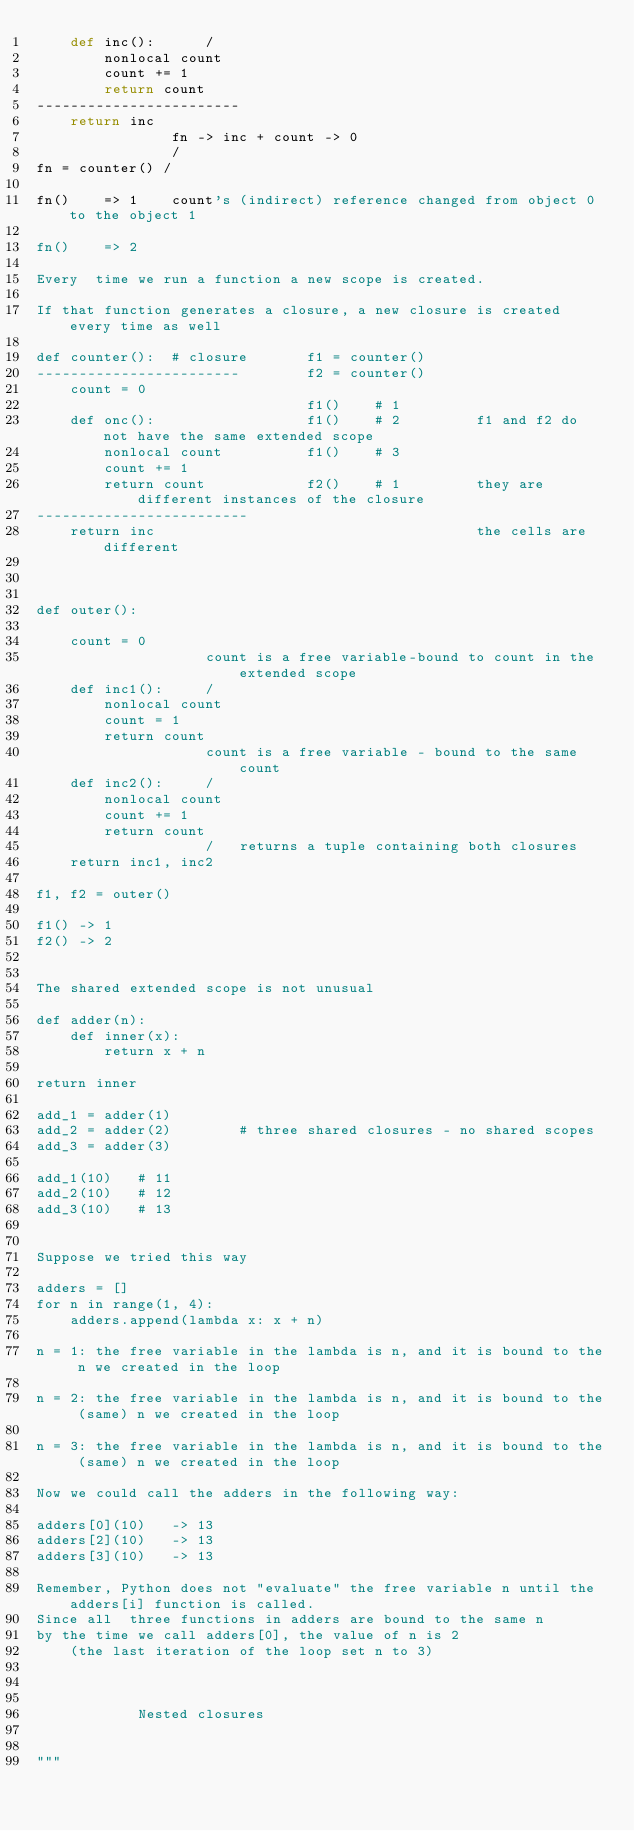<code> <loc_0><loc_0><loc_500><loc_500><_Python_>    def inc():      /
        nonlocal count
        count += 1
        return count
------------------------
    return inc
                fn -> inc + count -> 0
                /
fn = counter() /

fn()    => 1    count's (indirect) reference changed from object 0 to the object 1

fn()    => 2

Every  time we run a function a new scope is created.

If that function generates a closure, a new closure is created every time as well

def counter():  # closure       f1 = counter()
------------------------        f2 = counter()
    count = 0
                                f1()    # 1
    def onc():                  f1()    # 2         f1 and f2 do not have the same extended scope
        nonlocal count          f1()    # 3
        count += 1
        return count            f2()    # 1         they are different instances of the closure
-------------------------
    return inc                                      the cells are different



def outer():

    count = 0
                    count is a free variable-bound to count in the extended scope
    def inc1():     /
        nonlocal count
        count = 1
        return count
                    count is a free variable - bound to the same count
    def inc2():     /
        nonlocal count
        count += 1
        return count
                    /   returns a tuple containing both closures
    return inc1, inc2

f1, f2 = outer()

f1() -> 1
f2() -> 2


The shared extended scope is not unusual

def adder(n):
    def inner(x):
        return x + n

return inner

add_1 = adder(1)
add_2 = adder(2)        # three shared closures - no shared scopes
add_3 = adder(3)

add_1(10)   # 11
add_2(10)   # 12
add_3(10)   # 13


Suppose we tried this way

adders = []
for n in range(1, 4):
    adders.append(lambda x: x + n)

n = 1: the free variable in the lambda is n, and it is bound to the n we created in the loop

n = 2: the free variable in the lambda is n, and it is bound to the (same) n we created in the loop

n = 3: the free variable in the lambda is n, and it is bound to the (same) n we created in the loop

Now we could call the adders in the following way:

adders[0](10)   -> 13
adders[2](10)   -> 13
adders[3](10)   -> 13

Remember, Python does not "evaluate" the free variable n until the adders[i] function is called.
Since all  three functions in adders are bound to the same n
by the time we call adders[0], the value of n is 2
    (the last iteration of the loop set n to 3)



            Nested closures


"""</code> 